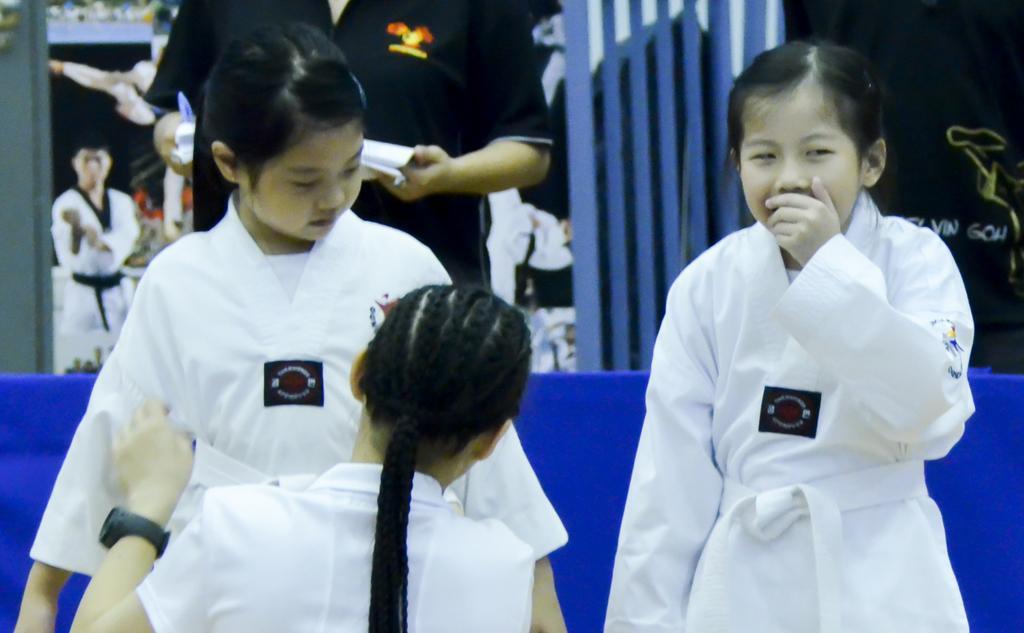How would you summarize this image in a sentence or two? In this image we can see people standing on the floor. In the background we can see the grills. 